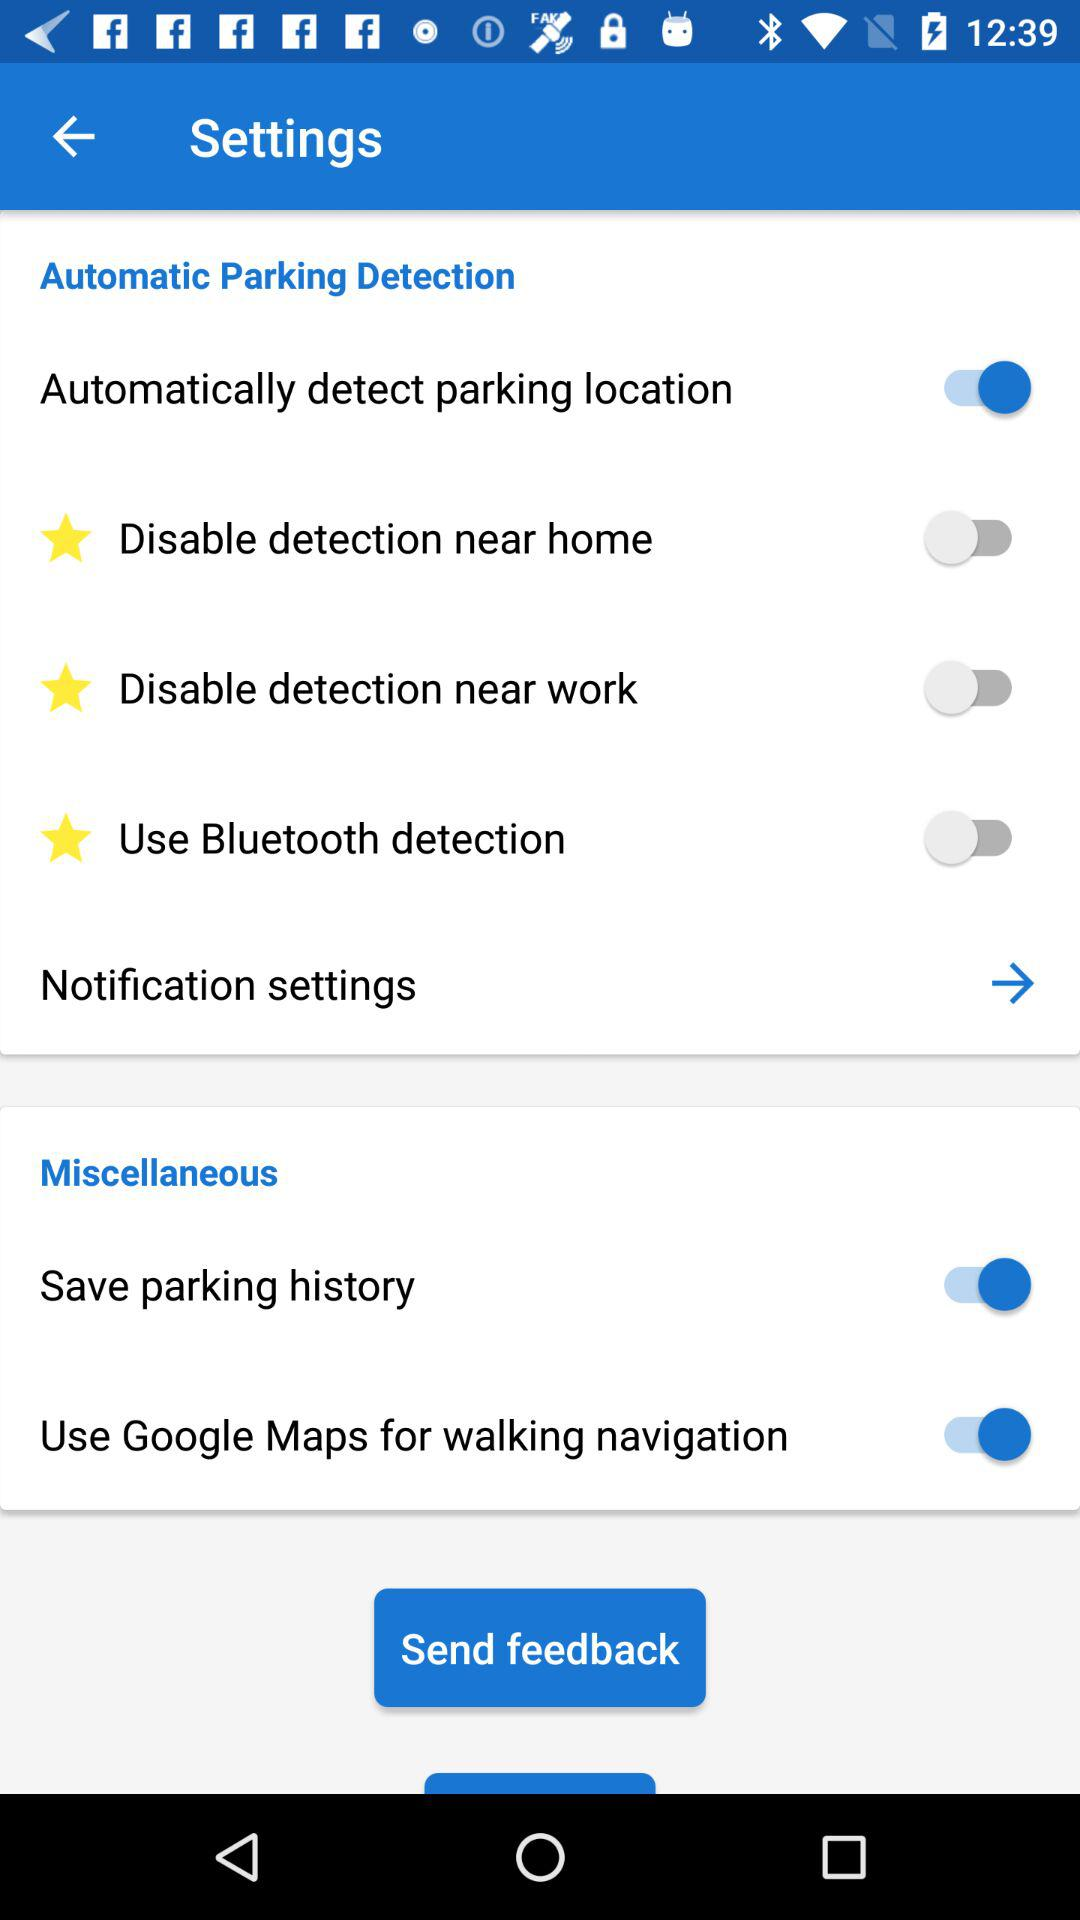How many switches are there in the Miscellaneous section?
Answer the question using a single word or phrase. 2 